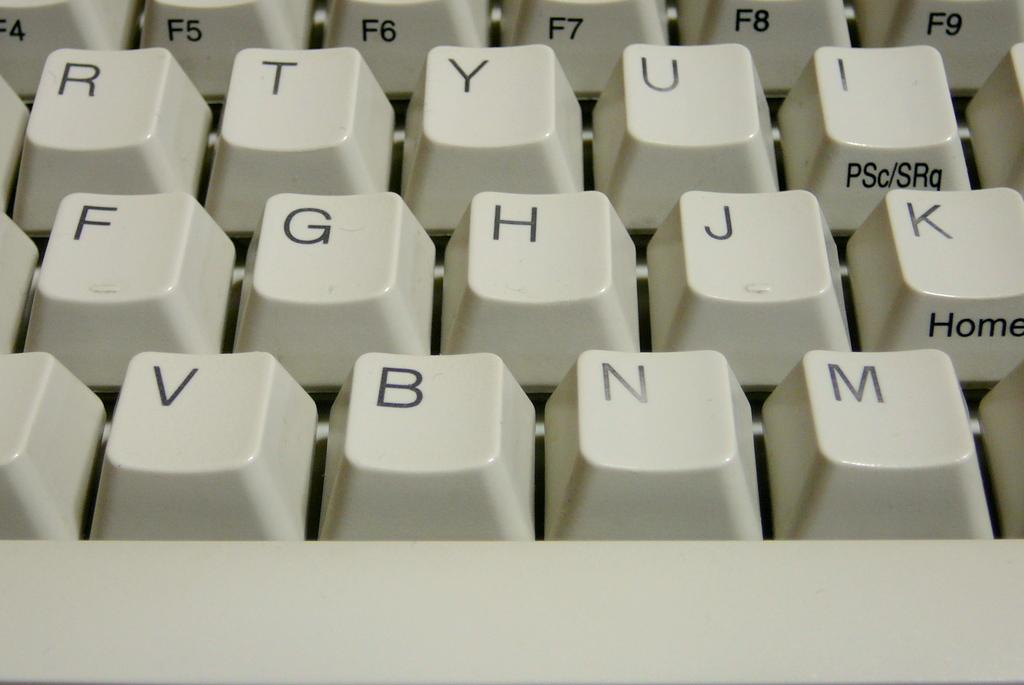Provide a one-sentence caption for the provided image. a beige keyboard with letters R T H N displayed along with Home button and F8 key. 